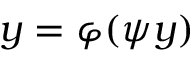Convert formula to latex. <formula><loc_0><loc_0><loc_500><loc_500>y = \varphi ( \psi y )</formula> 